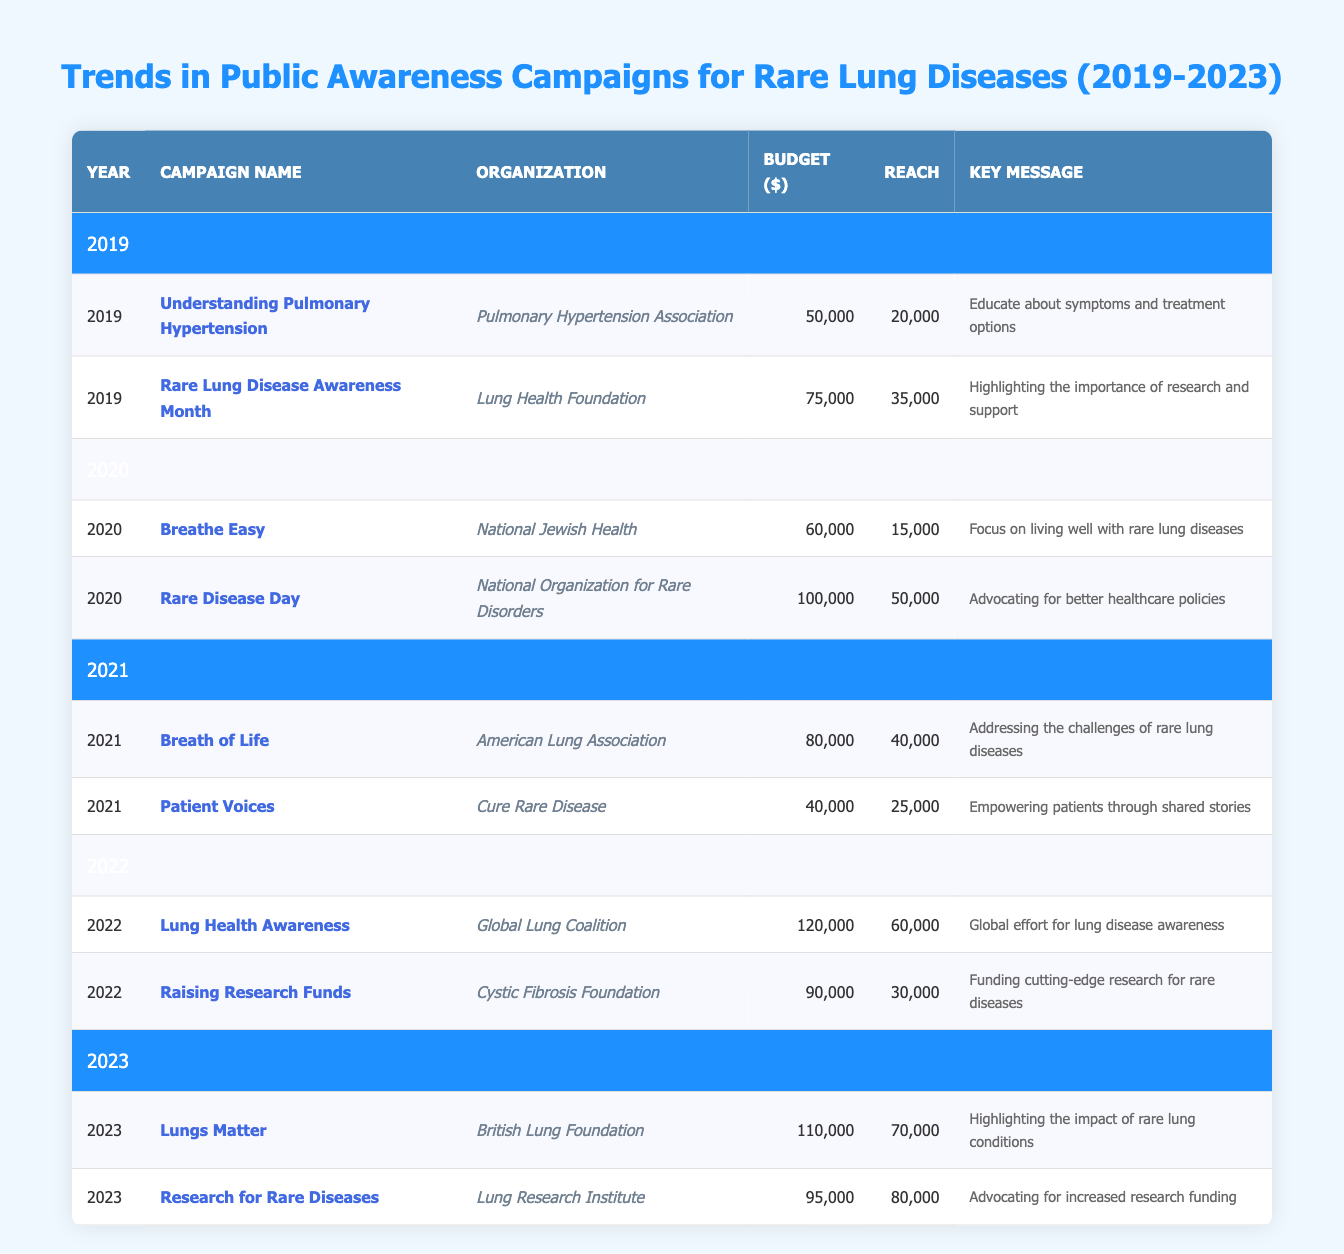What was the total budget for campaigns in 2022? The budget for 2022 consists of two campaigns: "Lung Health Awareness" with a budget of 120,000 and "Raising Research Funds" with a budget of 90,000. Adding these together gives a total budget of (120,000 + 90,000) = 210,000.
Answer: 210,000 Which organization had the highest reach in 2023? In 2023, the two campaigns are "Lungs Matter" with a reach of 70,000 and "Research for Rare Diseases" with a reach of 80,000. Comparing these values, the highest reach is 80,000 from the campaign by the Lung Research Institute.
Answer: 80,000 Did any campaigns have a budget over 100,000 in the past 5 years? Checking the budgets from 2019 to 2023, there are three campaigns with budgets over 100,000: in 2020, "Rare Disease Day" with 100,000; in 2022, "Lung Health Awareness" with 120,000; and in 2023, "Lungs Matter" with 110,000. Since there are campaigns with budgets exceeding 100,000, the answer is yes.
Answer: Yes What was the average reach of campaigns from 2019 to 2023? The reach values from 2019 to 2023 are: 20,000 (2019), 35,000 (2019), 15,000 (2020), 50,000 (2020), 40,000 (2021), 25,000 (2021), 60,000 (2022), 30,000 (2022), 70,000 (2023), and 80,000 (2023). There are 10 campaigns total. The total reach is (20,000 + 35,000 + 15,000 + 50,000 + 40,000 + 25,000 + 60,000 + 30,000 + 70,000 + 80,000) =  525,000, thus the average reach is 525,000 / 10 = 52,500.
Answer: 52,500 Which year had more campaigns focusing on healthcare policies, 2020 or 2021? In 2020, the campaign "Rare Disease Day" specifically advocates for better healthcare policies, while in 2021, neither campaign explicitly mentions healthcare policies. Thus, 2020 had more campaigns focused on this aspect, showing that there is one, whereas 2021 has none.
Answer: 2020 